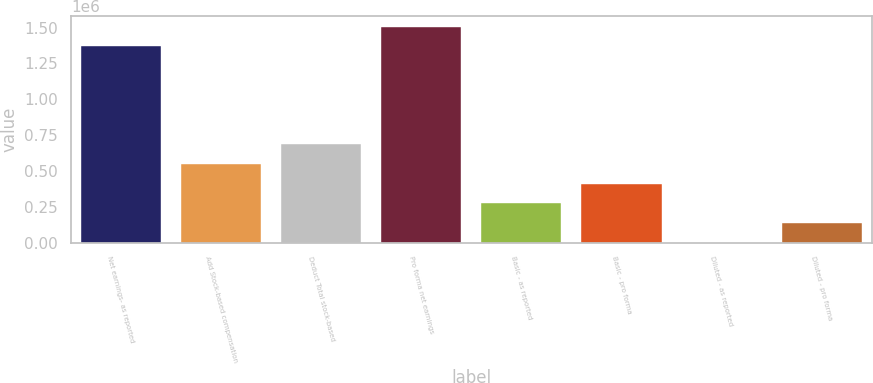Convert chart. <chart><loc_0><loc_0><loc_500><loc_500><bar_chart><fcel>Net earnings- as reported<fcel>Add Stock-based compensation<fcel>Deduct Total stock-based<fcel>Pro forma net earnings<fcel>Basic - as reported<fcel>Basic - pro forma<fcel>Diluted - as reported<fcel>Diluted - pro forma<nl><fcel>1.3699e+06<fcel>547964<fcel>684954<fcel>1.50689e+06<fcel>273984<fcel>410974<fcel>4.19<fcel>136994<nl></chart> 